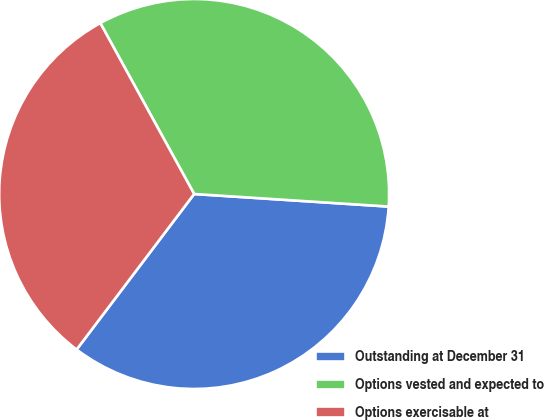<chart> <loc_0><loc_0><loc_500><loc_500><pie_chart><fcel>Outstanding at December 31<fcel>Options vested and expected to<fcel>Options exercisable at<nl><fcel>34.27%<fcel>34.02%<fcel>31.71%<nl></chart> 